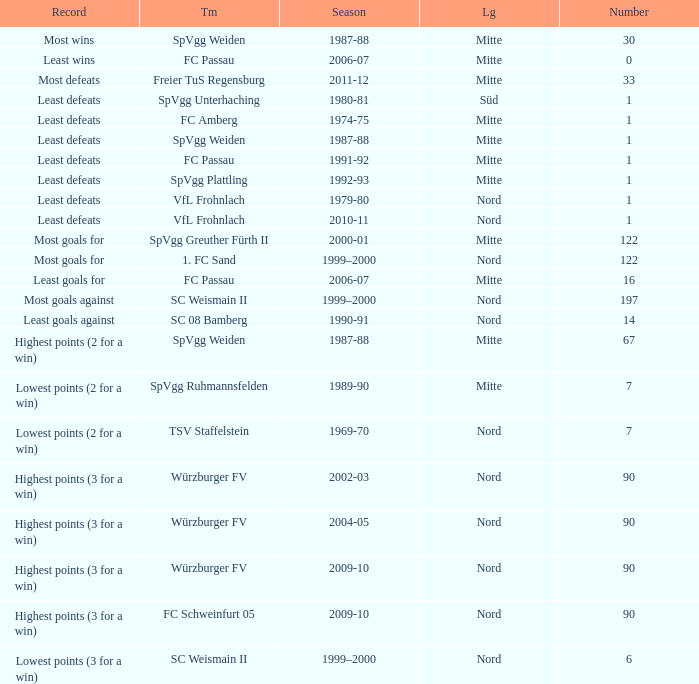What league has a number less than 122, and least wins as the record? Mitte. Parse the full table. {'header': ['Record', 'Tm', 'Season', 'Lg', 'Number'], 'rows': [['Most wins', 'SpVgg Weiden', '1987-88', 'Mitte', '30'], ['Least wins', 'FC Passau', '2006-07', 'Mitte', '0'], ['Most defeats', 'Freier TuS Regensburg', '2011-12', 'Mitte', '33'], ['Least defeats', 'SpVgg Unterhaching', '1980-81', 'Süd', '1'], ['Least defeats', 'FC Amberg', '1974-75', 'Mitte', '1'], ['Least defeats', 'SpVgg Weiden', '1987-88', 'Mitte', '1'], ['Least defeats', 'FC Passau', '1991-92', 'Mitte', '1'], ['Least defeats', 'SpVgg Plattling', '1992-93', 'Mitte', '1'], ['Least defeats', 'VfL Frohnlach', '1979-80', 'Nord', '1'], ['Least defeats', 'VfL Frohnlach', '2010-11', 'Nord', '1'], ['Most goals for', 'SpVgg Greuther Fürth II', '2000-01', 'Mitte', '122'], ['Most goals for', '1. FC Sand', '1999–2000', 'Nord', '122'], ['Least goals for', 'FC Passau', '2006-07', 'Mitte', '16'], ['Most goals against', 'SC Weismain II', '1999–2000', 'Nord', '197'], ['Least goals against', 'SC 08 Bamberg', '1990-91', 'Nord', '14'], ['Highest points (2 for a win)', 'SpVgg Weiden', '1987-88', 'Mitte', '67'], ['Lowest points (2 for a win)', 'SpVgg Ruhmannsfelden', '1989-90', 'Mitte', '7'], ['Lowest points (2 for a win)', 'TSV Staffelstein', '1969-70', 'Nord', '7'], ['Highest points (3 for a win)', 'Würzburger FV', '2002-03', 'Nord', '90'], ['Highest points (3 for a win)', 'Würzburger FV', '2004-05', 'Nord', '90'], ['Highest points (3 for a win)', 'Würzburger FV', '2009-10', 'Nord', '90'], ['Highest points (3 for a win)', 'FC Schweinfurt 05', '2009-10', 'Nord', '90'], ['Lowest points (3 for a win)', 'SC Weismain II', '1999–2000', 'Nord', '6']]} 